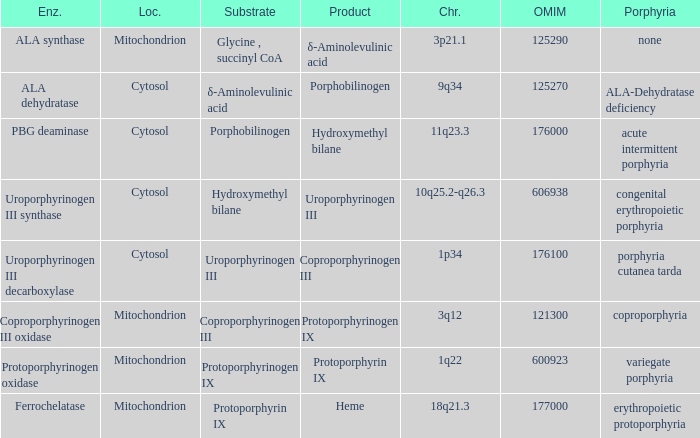Which substrate has an OMIM of 176000? Porphobilinogen. 